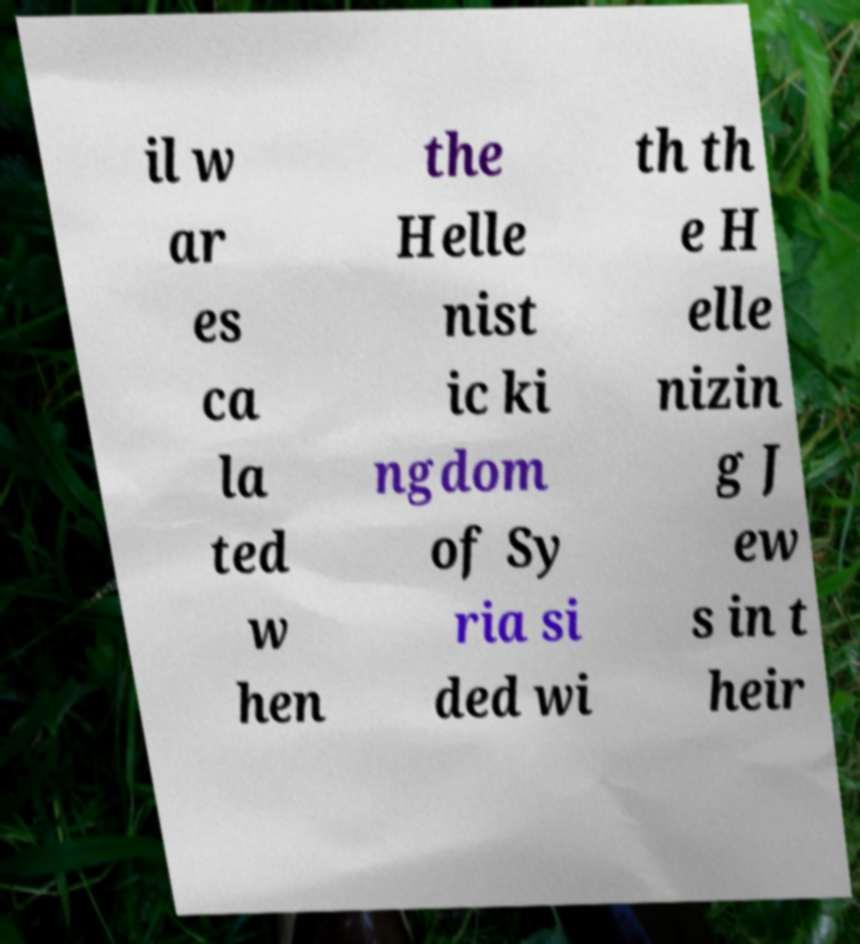What messages or text are displayed in this image? I need them in a readable, typed format. il w ar es ca la ted w hen the Helle nist ic ki ngdom of Sy ria si ded wi th th e H elle nizin g J ew s in t heir 